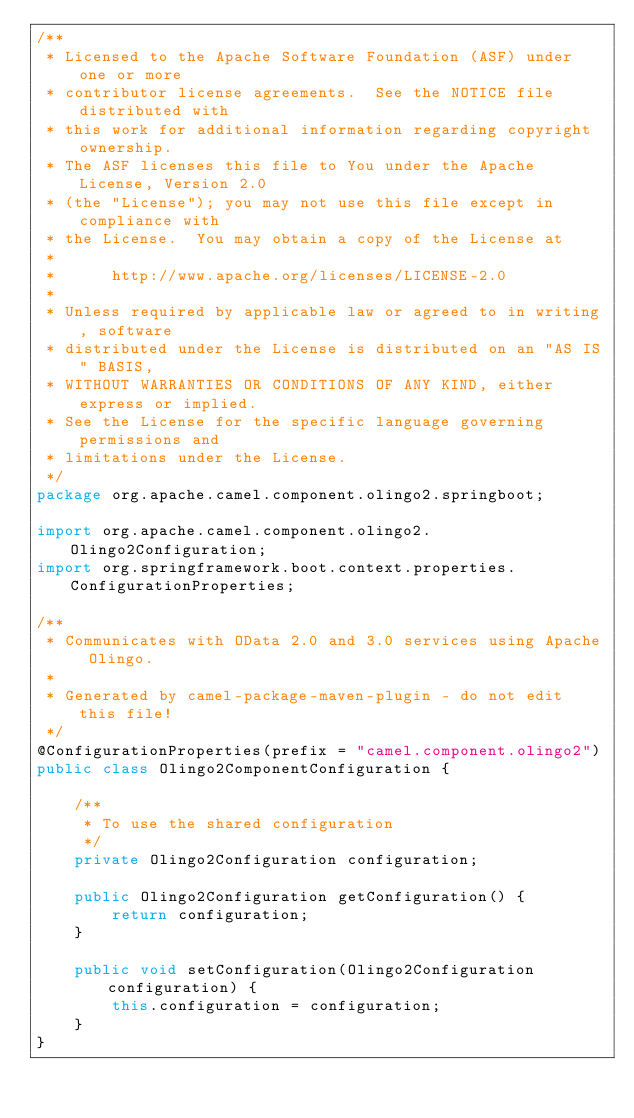<code> <loc_0><loc_0><loc_500><loc_500><_Java_>/**
 * Licensed to the Apache Software Foundation (ASF) under one or more
 * contributor license agreements.  See the NOTICE file distributed with
 * this work for additional information regarding copyright ownership.
 * The ASF licenses this file to You under the Apache License, Version 2.0
 * (the "License"); you may not use this file except in compliance with
 * the License.  You may obtain a copy of the License at
 *
 *      http://www.apache.org/licenses/LICENSE-2.0
 *
 * Unless required by applicable law or agreed to in writing, software
 * distributed under the License is distributed on an "AS IS" BASIS,
 * WITHOUT WARRANTIES OR CONDITIONS OF ANY KIND, either express or implied.
 * See the License for the specific language governing permissions and
 * limitations under the License.
 */
package org.apache.camel.component.olingo2.springboot;

import org.apache.camel.component.olingo2.Olingo2Configuration;
import org.springframework.boot.context.properties.ConfigurationProperties;

/**
 * Communicates with OData 2.0 and 3.0 services using Apache Olingo.
 * 
 * Generated by camel-package-maven-plugin - do not edit this file!
 */
@ConfigurationProperties(prefix = "camel.component.olingo2")
public class Olingo2ComponentConfiguration {

    /**
     * To use the shared configuration
     */
    private Olingo2Configuration configuration;

    public Olingo2Configuration getConfiguration() {
        return configuration;
    }

    public void setConfiguration(Olingo2Configuration configuration) {
        this.configuration = configuration;
    }
}</code> 